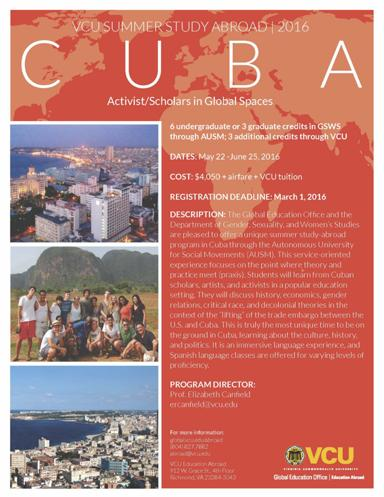Can you tell me more about the program director mentioned in the flyer? The program director for the VCU Summer Study Abroad 2016 in Cuba is Prof. Elizabeth Currin. Her expertise and guidance are expected to enrich the learning experience, emphasizing critical and activist scholarship within the program's global context. 